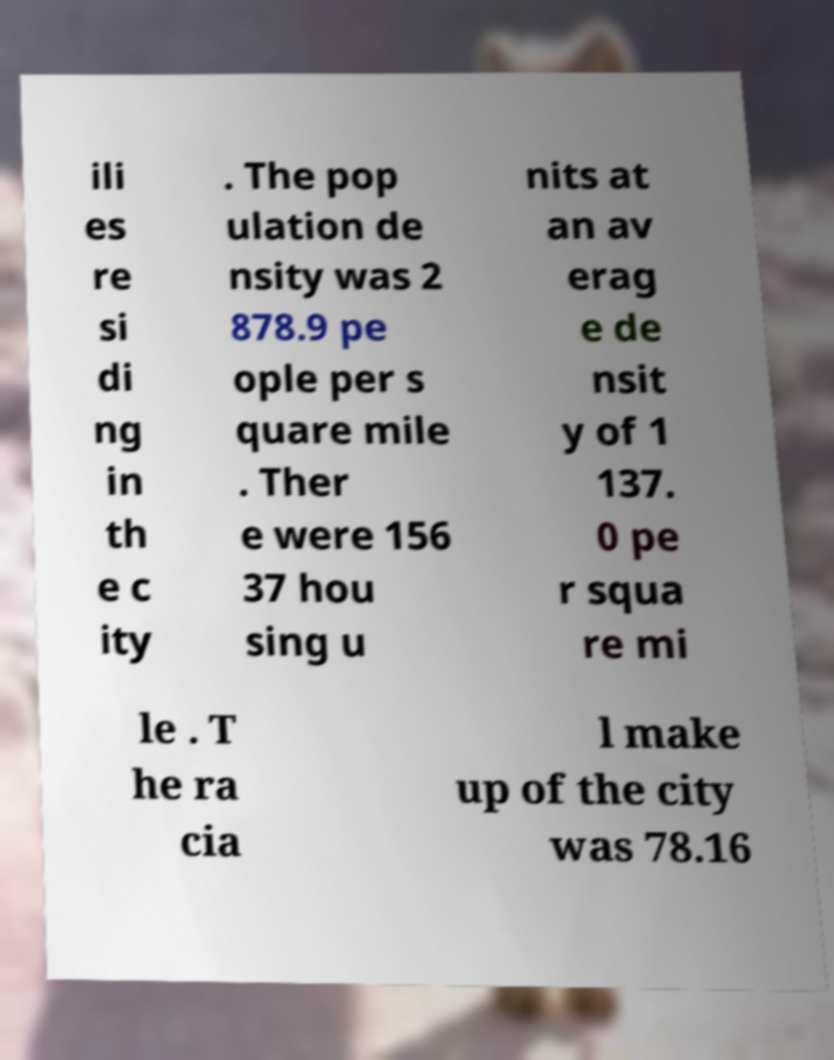Could you assist in decoding the text presented in this image and type it out clearly? ili es re si di ng in th e c ity . The pop ulation de nsity was 2 878.9 pe ople per s quare mile . Ther e were 156 37 hou sing u nits at an av erag e de nsit y of 1 137. 0 pe r squa re mi le . T he ra cia l make up of the city was 78.16 